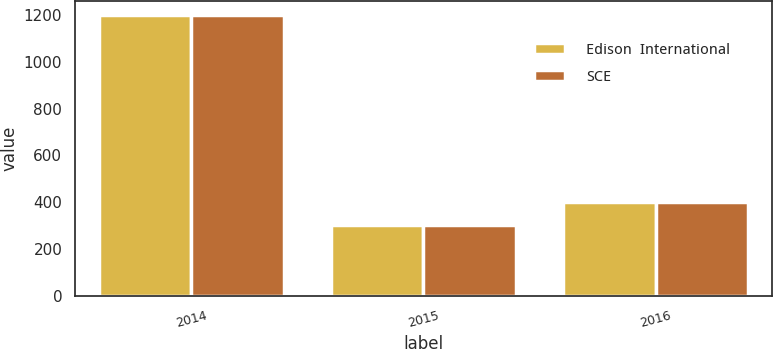<chart> <loc_0><loc_0><loc_500><loc_500><stacked_bar_chart><ecel><fcel>2014<fcel>2015<fcel>2016<nl><fcel>Edison  International<fcel>1200<fcel>300<fcel>400<nl><fcel>SCE<fcel>1200<fcel>300<fcel>400<nl></chart> 